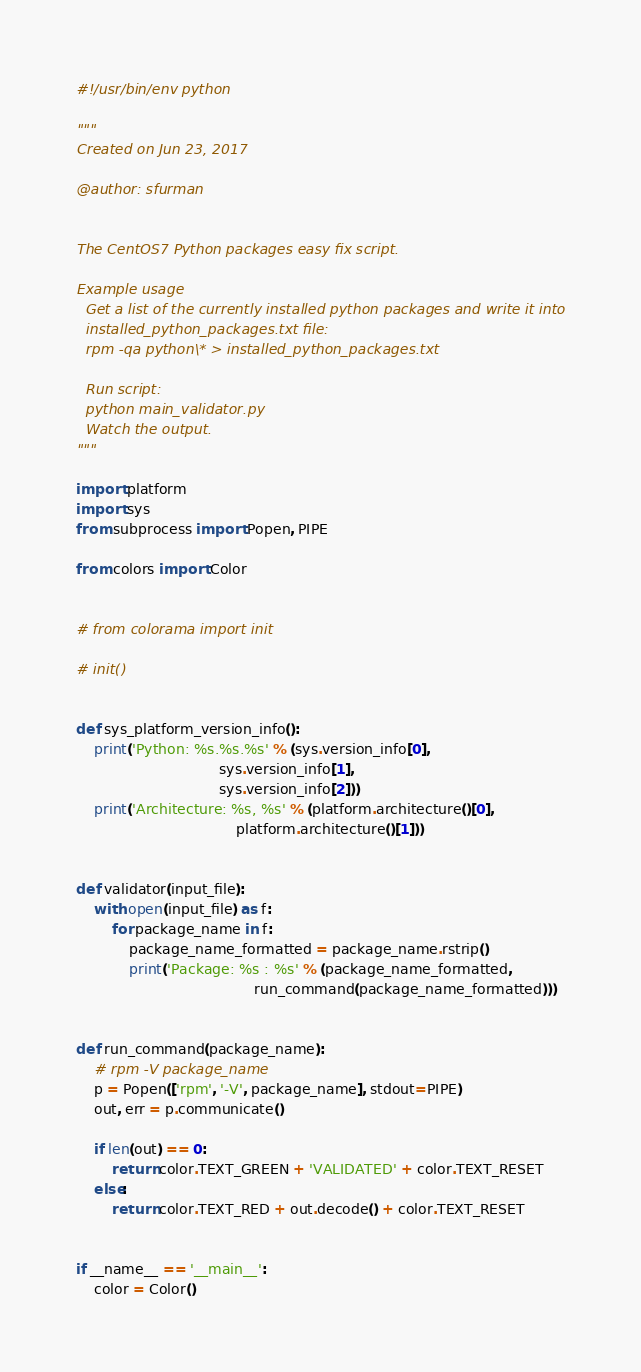<code> <loc_0><loc_0><loc_500><loc_500><_Python_>#!/usr/bin/env python

"""
Created on Jun 23, 2017

@author: sfurman


The CentOS7 Python packages easy fix script.

Example usage
  Get a list of the currently installed python packages and write it into
  installed_python_packages.txt file:
  rpm -qa python\* > installed_python_packages.txt

  Run script:
  python main_validator.py
  Watch the output.
"""

import platform
import sys
from subprocess import Popen, PIPE

from colors import Color


# from colorama import init

# init()


def sys_platform_version_info():
    print('Python: %s.%s.%s' % (sys.version_info[0],
                                sys.version_info[1],
                                sys.version_info[2]))
    print('Architecture: %s, %s' % (platform.architecture()[0],
                                    platform.architecture()[1]))


def validator(input_file):
    with open(input_file) as f:
        for package_name in f:
            package_name_formatted = package_name.rstrip()
            print('Package: %s : %s' % (package_name_formatted,
                                        run_command(package_name_formatted)))


def run_command(package_name):
    # rpm -V package_name
    p = Popen(['rpm', '-V', package_name], stdout=PIPE)
    out, err = p.communicate()

    if len(out) == 0:
        return color.TEXT_GREEN + 'VALIDATED' + color.TEXT_RESET
    else:
        return color.TEXT_RED + out.decode() + color.TEXT_RESET


if __name__ == '__main__':
    color = Color()
</code> 